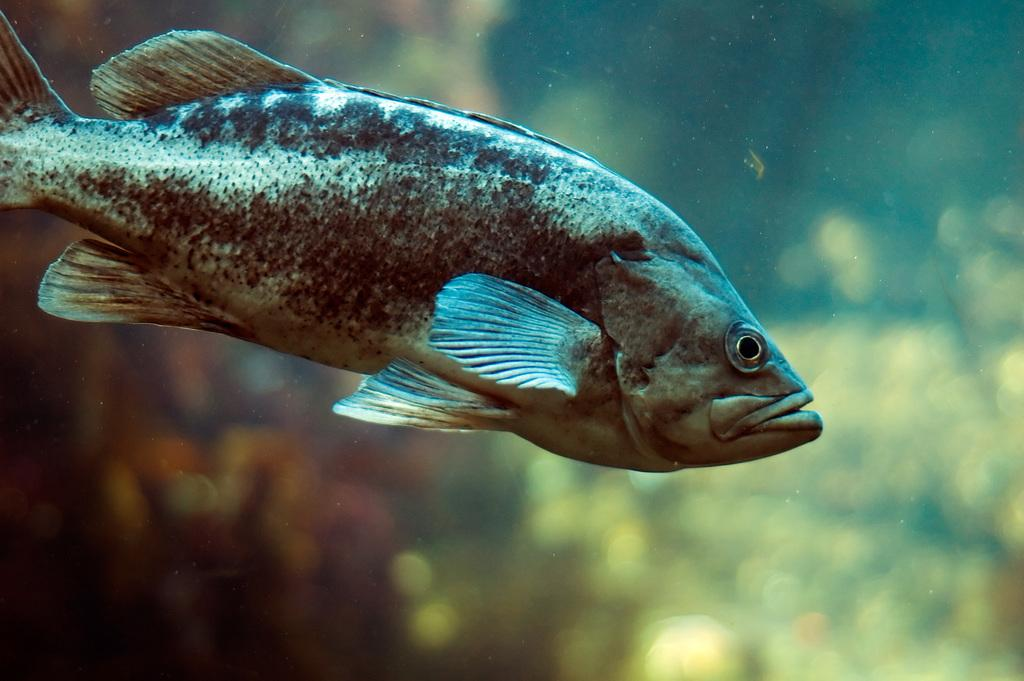What is the main subject of the image? There is a fish in the image. Can you describe the setting of the image? The image appears to be taken in the water. How many balls can be seen floating near the fish in the image? There are no balls present in the image; it features a fish in the water. What type of sheep is visible in the image? There are no sheep present in the image. 